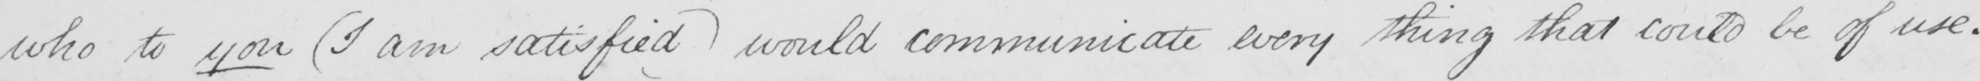Transcribe the text shown in this historical manuscript line. who to you  ( I am satisfied )  would communicate every thing that could be of use . 